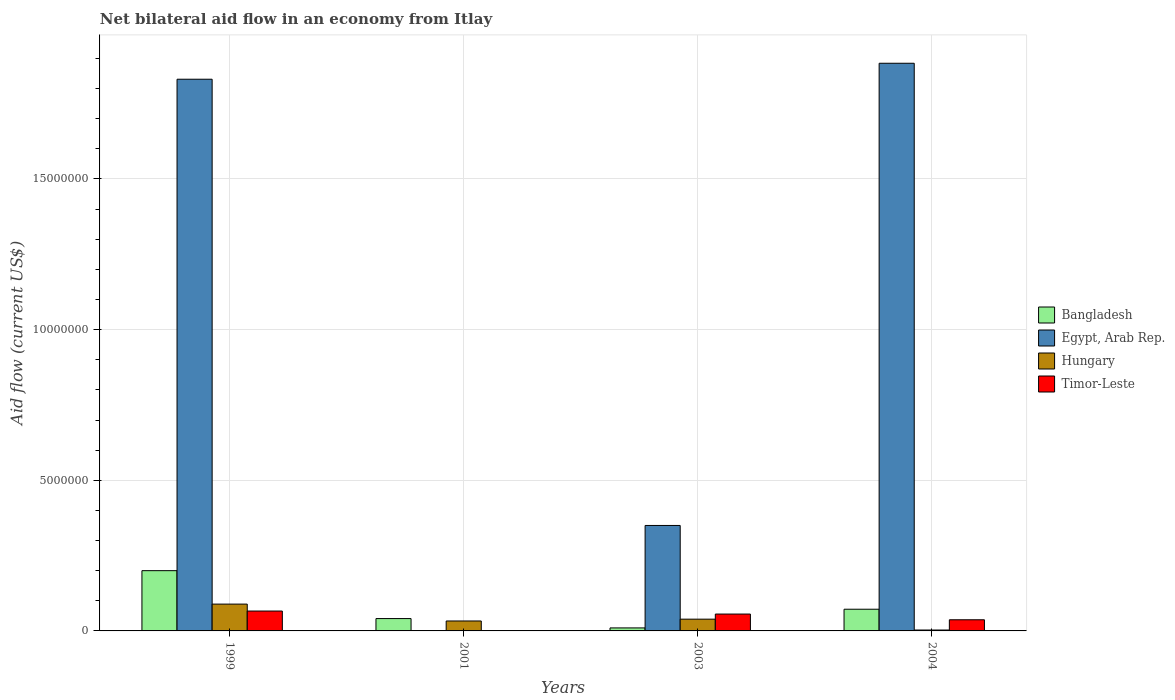How many different coloured bars are there?
Offer a very short reply. 4. How many groups of bars are there?
Offer a very short reply. 4. Are the number of bars per tick equal to the number of legend labels?
Provide a succinct answer. No. How many bars are there on the 3rd tick from the left?
Your response must be concise. 4. How many bars are there on the 1st tick from the right?
Offer a very short reply. 4. What is the label of the 3rd group of bars from the left?
Your response must be concise. 2003. In how many cases, is the number of bars for a given year not equal to the number of legend labels?
Your answer should be very brief. 1. Across all years, what is the maximum net bilateral aid flow in Timor-Leste?
Your answer should be very brief. 6.60e+05. Across all years, what is the minimum net bilateral aid flow in Bangladesh?
Your answer should be very brief. 1.00e+05. In which year was the net bilateral aid flow in Timor-Leste maximum?
Your response must be concise. 1999. What is the total net bilateral aid flow in Bangladesh in the graph?
Offer a very short reply. 3.23e+06. What is the difference between the net bilateral aid flow in Bangladesh in 1999 and that in 2003?
Provide a short and direct response. 1.90e+06. What is the difference between the net bilateral aid flow in Timor-Leste in 2003 and the net bilateral aid flow in Egypt, Arab Rep. in 2001?
Provide a short and direct response. 5.60e+05. What is the average net bilateral aid flow in Egypt, Arab Rep. per year?
Offer a terse response. 1.02e+07. In the year 2004, what is the difference between the net bilateral aid flow in Egypt, Arab Rep. and net bilateral aid flow in Hungary?
Give a very brief answer. 1.88e+07. In how many years, is the net bilateral aid flow in Hungary greater than 6000000 US$?
Offer a terse response. 0. What is the ratio of the net bilateral aid flow in Hungary in 1999 to that in 2004?
Your answer should be very brief. 29.67. Is the net bilateral aid flow in Timor-Leste in 1999 less than that in 2004?
Ensure brevity in your answer.  No. Is the difference between the net bilateral aid flow in Egypt, Arab Rep. in 1999 and 2004 greater than the difference between the net bilateral aid flow in Hungary in 1999 and 2004?
Your answer should be very brief. No. What is the difference between the highest and the second highest net bilateral aid flow in Egypt, Arab Rep.?
Provide a short and direct response. 5.30e+05. What is the difference between the highest and the lowest net bilateral aid flow in Timor-Leste?
Your answer should be very brief. 6.50e+05. In how many years, is the net bilateral aid flow in Egypt, Arab Rep. greater than the average net bilateral aid flow in Egypt, Arab Rep. taken over all years?
Offer a terse response. 2. Is the sum of the net bilateral aid flow in Hungary in 2001 and 2004 greater than the maximum net bilateral aid flow in Timor-Leste across all years?
Offer a very short reply. No. Is it the case that in every year, the sum of the net bilateral aid flow in Bangladesh and net bilateral aid flow in Timor-Leste is greater than the net bilateral aid flow in Hungary?
Ensure brevity in your answer.  Yes. How many bars are there?
Your response must be concise. 15. Are all the bars in the graph horizontal?
Your answer should be very brief. No. What is the difference between two consecutive major ticks on the Y-axis?
Provide a short and direct response. 5.00e+06. Does the graph contain grids?
Provide a short and direct response. Yes. Where does the legend appear in the graph?
Your answer should be very brief. Center right. How are the legend labels stacked?
Offer a terse response. Vertical. What is the title of the graph?
Your response must be concise. Net bilateral aid flow in an economy from Itlay. Does "East Asia (all income levels)" appear as one of the legend labels in the graph?
Make the answer very short. No. What is the label or title of the Y-axis?
Make the answer very short. Aid flow (current US$). What is the Aid flow (current US$) of Bangladesh in 1999?
Give a very brief answer. 2.00e+06. What is the Aid flow (current US$) of Egypt, Arab Rep. in 1999?
Your answer should be compact. 1.83e+07. What is the Aid flow (current US$) in Hungary in 1999?
Ensure brevity in your answer.  8.90e+05. What is the Aid flow (current US$) in Timor-Leste in 1999?
Offer a terse response. 6.60e+05. What is the Aid flow (current US$) of Bangladesh in 2001?
Provide a short and direct response. 4.10e+05. What is the Aid flow (current US$) of Egypt, Arab Rep. in 2003?
Offer a terse response. 3.50e+06. What is the Aid flow (current US$) in Timor-Leste in 2003?
Make the answer very short. 5.60e+05. What is the Aid flow (current US$) of Bangladesh in 2004?
Your answer should be very brief. 7.20e+05. What is the Aid flow (current US$) of Egypt, Arab Rep. in 2004?
Your answer should be very brief. 1.88e+07. What is the Aid flow (current US$) in Hungary in 2004?
Your answer should be compact. 3.00e+04. Across all years, what is the maximum Aid flow (current US$) in Egypt, Arab Rep.?
Give a very brief answer. 1.88e+07. Across all years, what is the maximum Aid flow (current US$) in Hungary?
Provide a succinct answer. 8.90e+05. Across all years, what is the maximum Aid flow (current US$) in Timor-Leste?
Your answer should be compact. 6.60e+05. Across all years, what is the minimum Aid flow (current US$) in Hungary?
Give a very brief answer. 3.00e+04. What is the total Aid flow (current US$) in Bangladesh in the graph?
Provide a succinct answer. 3.23e+06. What is the total Aid flow (current US$) in Egypt, Arab Rep. in the graph?
Keep it short and to the point. 4.06e+07. What is the total Aid flow (current US$) of Hungary in the graph?
Offer a terse response. 1.64e+06. What is the total Aid flow (current US$) in Timor-Leste in the graph?
Your response must be concise. 1.60e+06. What is the difference between the Aid flow (current US$) in Bangladesh in 1999 and that in 2001?
Your answer should be compact. 1.59e+06. What is the difference between the Aid flow (current US$) of Hungary in 1999 and that in 2001?
Your response must be concise. 5.60e+05. What is the difference between the Aid flow (current US$) of Timor-Leste in 1999 and that in 2001?
Keep it short and to the point. 6.50e+05. What is the difference between the Aid flow (current US$) of Bangladesh in 1999 and that in 2003?
Ensure brevity in your answer.  1.90e+06. What is the difference between the Aid flow (current US$) of Egypt, Arab Rep. in 1999 and that in 2003?
Your response must be concise. 1.48e+07. What is the difference between the Aid flow (current US$) of Bangladesh in 1999 and that in 2004?
Your answer should be compact. 1.28e+06. What is the difference between the Aid flow (current US$) of Egypt, Arab Rep. in 1999 and that in 2004?
Provide a succinct answer. -5.30e+05. What is the difference between the Aid flow (current US$) of Hungary in 1999 and that in 2004?
Provide a succinct answer. 8.60e+05. What is the difference between the Aid flow (current US$) of Hungary in 2001 and that in 2003?
Give a very brief answer. -6.00e+04. What is the difference between the Aid flow (current US$) in Timor-Leste in 2001 and that in 2003?
Offer a terse response. -5.50e+05. What is the difference between the Aid flow (current US$) of Bangladesh in 2001 and that in 2004?
Your answer should be compact. -3.10e+05. What is the difference between the Aid flow (current US$) of Hungary in 2001 and that in 2004?
Make the answer very short. 3.00e+05. What is the difference between the Aid flow (current US$) in Timor-Leste in 2001 and that in 2004?
Your response must be concise. -3.60e+05. What is the difference between the Aid flow (current US$) in Bangladesh in 2003 and that in 2004?
Keep it short and to the point. -6.20e+05. What is the difference between the Aid flow (current US$) of Egypt, Arab Rep. in 2003 and that in 2004?
Offer a terse response. -1.53e+07. What is the difference between the Aid flow (current US$) of Timor-Leste in 2003 and that in 2004?
Ensure brevity in your answer.  1.90e+05. What is the difference between the Aid flow (current US$) in Bangladesh in 1999 and the Aid flow (current US$) in Hungary in 2001?
Your answer should be very brief. 1.67e+06. What is the difference between the Aid flow (current US$) of Bangladesh in 1999 and the Aid flow (current US$) of Timor-Leste in 2001?
Give a very brief answer. 1.99e+06. What is the difference between the Aid flow (current US$) of Egypt, Arab Rep. in 1999 and the Aid flow (current US$) of Hungary in 2001?
Offer a very short reply. 1.80e+07. What is the difference between the Aid flow (current US$) in Egypt, Arab Rep. in 1999 and the Aid flow (current US$) in Timor-Leste in 2001?
Provide a short and direct response. 1.83e+07. What is the difference between the Aid flow (current US$) of Hungary in 1999 and the Aid flow (current US$) of Timor-Leste in 2001?
Offer a very short reply. 8.80e+05. What is the difference between the Aid flow (current US$) in Bangladesh in 1999 and the Aid flow (current US$) in Egypt, Arab Rep. in 2003?
Offer a terse response. -1.50e+06. What is the difference between the Aid flow (current US$) of Bangladesh in 1999 and the Aid flow (current US$) of Hungary in 2003?
Offer a very short reply. 1.61e+06. What is the difference between the Aid flow (current US$) of Bangladesh in 1999 and the Aid flow (current US$) of Timor-Leste in 2003?
Keep it short and to the point. 1.44e+06. What is the difference between the Aid flow (current US$) in Egypt, Arab Rep. in 1999 and the Aid flow (current US$) in Hungary in 2003?
Make the answer very short. 1.79e+07. What is the difference between the Aid flow (current US$) of Egypt, Arab Rep. in 1999 and the Aid flow (current US$) of Timor-Leste in 2003?
Ensure brevity in your answer.  1.78e+07. What is the difference between the Aid flow (current US$) of Bangladesh in 1999 and the Aid flow (current US$) of Egypt, Arab Rep. in 2004?
Ensure brevity in your answer.  -1.68e+07. What is the difference between the Aid flow (current US$) of Bangladesh in 1999 and the Aid flow (current US$) of Hungary in 2004?
Provide a succinct answer. 1.97e+06. What is the difference between the Aid flow (current US$) in Bangladesh in 1999 and the Aid flow (current US$) in Timor-Leste in 2004?
Your answer should be compact. 1.63e+06. What is the difference between the Aid flow (current US$) in Egypt, Arab Rep. in 1999 and the Aid flow (current US$) in Hungary in 2004?
Your response must be concise. 1.83e+07. What is the difference between the Aid flow (current US$) of Egypt, Arab Rep. in 1999 and the Aid flow (current US$) of Timor-Leste in 2004?
Keep it short and to the point. 1.79e+07. What is the difference between the Aid flow (current US$) of Hungary in 1999 and the Aid flow (current US$) of Timor-Leste in 2004?
Keep it short and to the point. 5.20e+05. What is the difference between the Aid flow (current US$) of Bangladesh in 2001 and the Aid flow (current US$) of Egypt, Arab Rep. in 2003?
Provide a succinct answer. -3.09e+06. What is the difference between the Aid flow (current US$) in Bangladesh in 2001 and the Aid flow (current US$) in Hungary in 2003?
Provide a short and direct response. 2.00e+04. What is the difference between the Aid flow (current US$) in Bangladesh in 2001 and the Aid flow (current US$) in Timor-Leste in 2003?
Keep it short and to the point. -1.50e+05. What is the difference between the Aid flow (current US$) of Hungary in 2001 and the Aid flow (current US$) of Timor-Leste in 2003?
Your answer should be compact. -2.30e+05. What is the difference between the Aid flow (current US$) in Bangladesh in 2001 and the Aid flow (current US$) in Egypt, Arab Rep. in 2004?
Offer a terse response. -1.84e+07. What is the difference between the Aid flow (current US$) in Bangladesh in 2001 and the Aid flow (current US$) in Hungary in 2004?
Provide a short and direct response. 3.80e+05. What is the difference between the Aid flow (current US$) in Bangladesh in 2003 and the Aid flow (current US$) in Egypt, Arab Rep. in 2004?
Provide a short and direct response. -1.87e+07. What is the difference between the Aid flow (current US$) of Egypt, Arab Rep. in 2003 and the Aid flow (current US$) of Hungary in 2004?
Keep it short and to the point. 3.47e+06. What is the difference between the Aid flow (current US$) in Egypt, Arab Rep. in 2003 and the Aid flow (current US$) in Timor-Leste in 2004?
Ensure brevity in your answer.  3.13e+06. What is the difference between the Aid flow (current US$) of Hungary in 2003 and the Aid flow (current US$) of Timor-Leste in 2004?
Make the answer very short. 2.00e+04. What is the average Aid flow (current US$) in Bangladesh per year?
Your answer should be compact. 8.08e+05. What is the average Aid flow (current US$) of Egypt, Arab Rep. per year?
Offer a terse response. 1.02e+07. What is the average Aid flow (current US$) of Timor-Leste per year?
Provide a succinct answer. 4.00e+05. In the year 1999, what is the difference between the Aid flow (current US$) in Bangladesh and Aid flow (current US$) in Egypt, Arab Rep.?
Your response must be concise. -1.63e+07. In the year 1999, what is the difference between the Aid flow (current US$) of Bangladesh and Aid flow (current US$) of Hungary?
Your answer should be compact. 1.11e+06. In the year 1999, what is the difference between the Aid flow (current US$) in Bangladesh and Aid flow (current US$) in Timor-Leste?
Provide a succinct answer. 1.34e+06. In the year 1999, what is the difference between the Aid flow (current US$) in Egypt, Arab Rep. and Aid flow (current US$) in Hungary?
Ensure brevity in your answer.  1.74e+07. In the year 1999, what is the difference between the Aid flow (current US$) of Egypt, Arab Rep. and Aid flow (current US$) of Timor-Leste?
Give a very brief answer. 1.76e+07. In the year 1999, what is the difference between the Aid flow (current US$) in Hungary and Aid flow (current US$) in Timor-Leste?
Your answer should be very brief. 2.30e+05. In the year 2001, what is the difference between the Aid flow (current US$) in Hungary and Aid flow (current US$) in Timor-Leste?
Offer a terse response. 3.20e+05. In the year 2003, what is the difference between the Aid flow (current US$) in Bangladesh and Aid flow (current US$) in Egypt, Arab Rep.?
Your answer should be very brief. -3.40e+06. In the year 2003, what is the difference between the Aid flow (current US$) in Bangladesh and Aid flow (current US$) in Hungary?
Ensure brevity in your answer.  -2.90e+05. In the year 2003, what is the difference between the Aid flow (current US$) of Bangladesh and Aid flow (current US$) of Timor-Leste?
Offer a very short reply. -4.60e+05. In the year 2003, what is the difference between the Aid flow (current US$) of Egypt, Arab Rep. and Aid flow (current US$) of Hungary?
Your answer should be very brief. 3.11e+06. In the year 2003, what is the difference between the Aid flow (current US$) in Egypt, Arab Rep. and Aid flow (current US$) in Timor-Leste?
Provide a succinct answer. 2.94e+06. In the year 2004, what is the difference between the Aid flow (current US$) of Bangladesh and Aid flow (current US$) of Egypt, Arab Rep.?
Give a very brief answer. -1.81e+07. In the year 2004, what is the difference between the Aid flow (current US$) of Bangladesh and Aid flow (current US$) of Hungary?
Make the answer very short. 6.90e+05. In the year 2004, what is the difference between the Aid flow (current US$) in Bangladesh and Aid flow (current US$) in Timor-Leste?
Your answer should be very brief. 3.50e+05. In the year 2004, what is the difference between the Aid flow (current US$) of Egypt, Arab Rep. and Aid flow (current US$) of Hungary?
Provide a short and direct response. 1.88e+07. In the year 2004, what is the difference between the Aid flow (current US$) of Egypt, Arab Rep. and Aid flow (current US$) of Timor-Leste?
Your answer should be compact. 1.85e+07. What is the ratio of the Aid flow (current US$) in Bangladesh in 1999 to that in 2001?
Give a very brief answer. 4.88. What is the ratio of the Aid flow (current US$) in Hungary in 1999 to that in 2001?
Offer a very short reply. 2.7. What is the ratio of the Aid flow (current US$) of Egypt, Arab Rep. in 1999 to that in 2003?
Give a very brief answer. 5.23. What is the ratio of the Aid flow (current US$) in Hungary in 1999 to that in 2003?
Offer a very short reply. 2.28. What is the ratio of the Aid flow (current US$) in Timor-Leste in 1999 to that in 2003?
Provide a short and direct response. 1.18. What is the ratio of the Aid flow (current US$) of Bangladesh in 1999 to that in 2004?
Provide a succinct answer. 2.78. What is the ratio of the Aid flow (current US$) in Egypt, Arab Rep. in 1999 to that in 2004?
Provide a short and direct response. 0.97. What is the ratio of the Aid flow (current US$) in Hungary in 1999 to that in 2004?
Ensure brevity in your answer.  29.67. What is the ratio of the Aid flow (current US$) in Timor-Leste in 1999 to that in 2004?
Ensure brevity in your answer.  1.78. What is the ratio of the Aid flow (current US$) of Hungary in 2001 to that in 2003?
Offer a very short reply. 0.85. What is the ratio of the Aid flow (current US$) in Timor-Leste in 2001 to that in 2003?
Provide a succinct answer. 0.02. What is the ratio of the Aid flow (current US$) of Bangladesh in 2001 to that in 2004?
Give a very brief answer. 0.57. What is the ratio of the Aid flow (current US$) in Hungary in 2001 to that in 2004?
Your answer should be compact. 11. What is the ratio of the Aid flow (current US$) of Timor-Leste in 2001 to that in 2004?
Provide a short and direct response. 0.03. What is the ratio of the Aid flow (current US$) in Bangladesh in 2003 to that in 2004?
Offer a terse response. 0.14. What is the ratio of the Aid flow (current US$) in Egypt, Arab Rep. in 2003 to that in 2004?
Provide a succinct answer. 0.19. What is the ratio of the Aid flow (current US$) in Timor-Leste in 2003 to that in 2004?
Give a very brief answer. 1.51. What is the difference between the highest and the second highest Aid flow (current US$) in Bangladesh?
Your answer should be very brief. 1.28e+06. What is the difference between the highest and the second highest Aid flow (current US$) of Egypt, Arab Rep.?
Your answer should be very brief. 5.30e+05. What is the difference between the highest and the second highest Aid flow (current US$) in Hungary?
Provide a succinct answer. 5.00e+05. What is the difference between the highest and the lowest Aid flow (current US$) in Bangladesh?
Your answer should be compact. 1.90e+06. What is the difference between the highest and the lowest Aid flow (current US$) of Egypt, Arab Rep.?
Your answer should be compact. 1.88e+07. What is the difference between the highest and the lowest Aid flow (current US$) in Hungary?
Ensure brevity in your answer.  8.60e+05. What is the difference between the highest and the lowest Aid flow (current US$) of Timor-Leste?
Provide a short and direct response. 6.50e+05. 